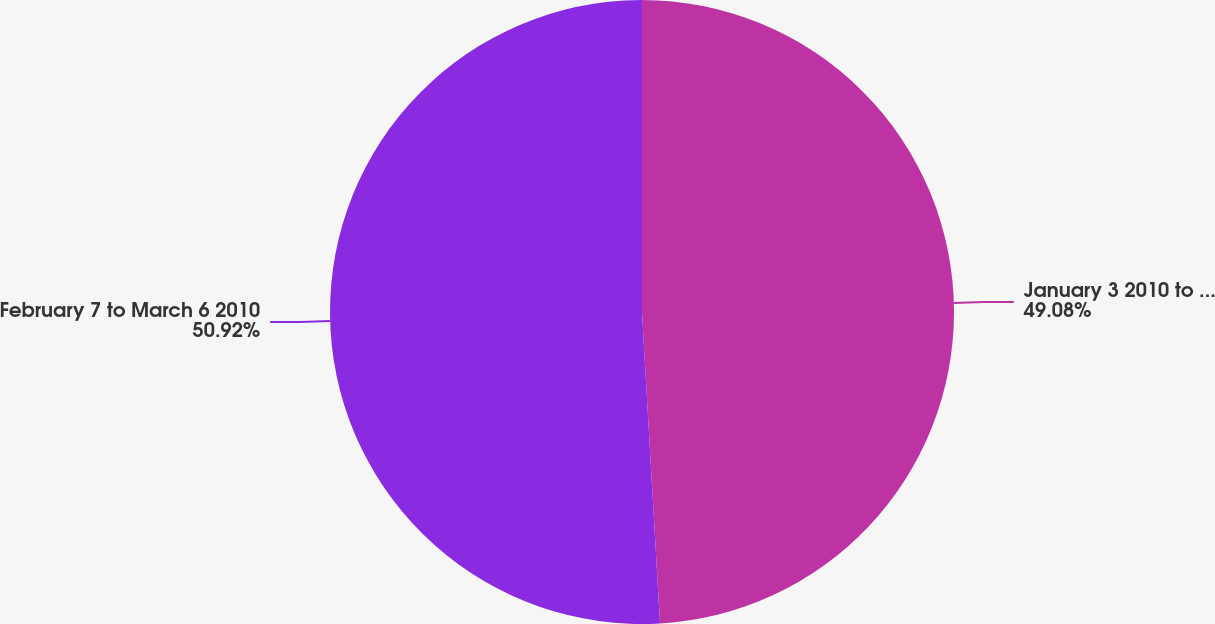<chart> <loc_0><loc_0><loc_500><loc_500><pie_chart><fcel>January 3 2010 to February 6<fcel>February 7 to March 6 2010<nl><fcel>49.08%<fcel>50.92%<nl></chart> 